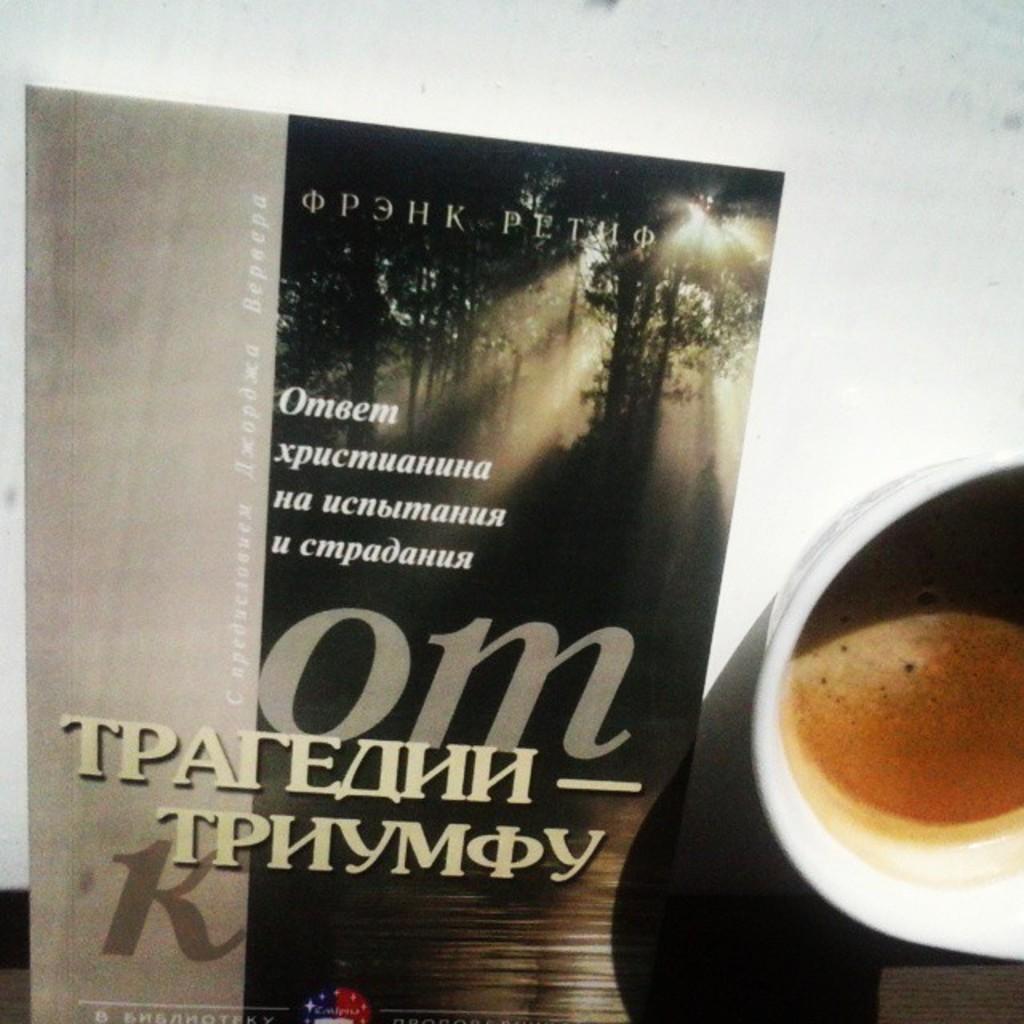In one or two sentences, can you explain what this image depicts? In the center of the image we can see one table and a few other objects. On the table, we can see one cup and poster. In the cup, we can see some liquid, which is in brown color. On the poster, we can see trees and some text. 